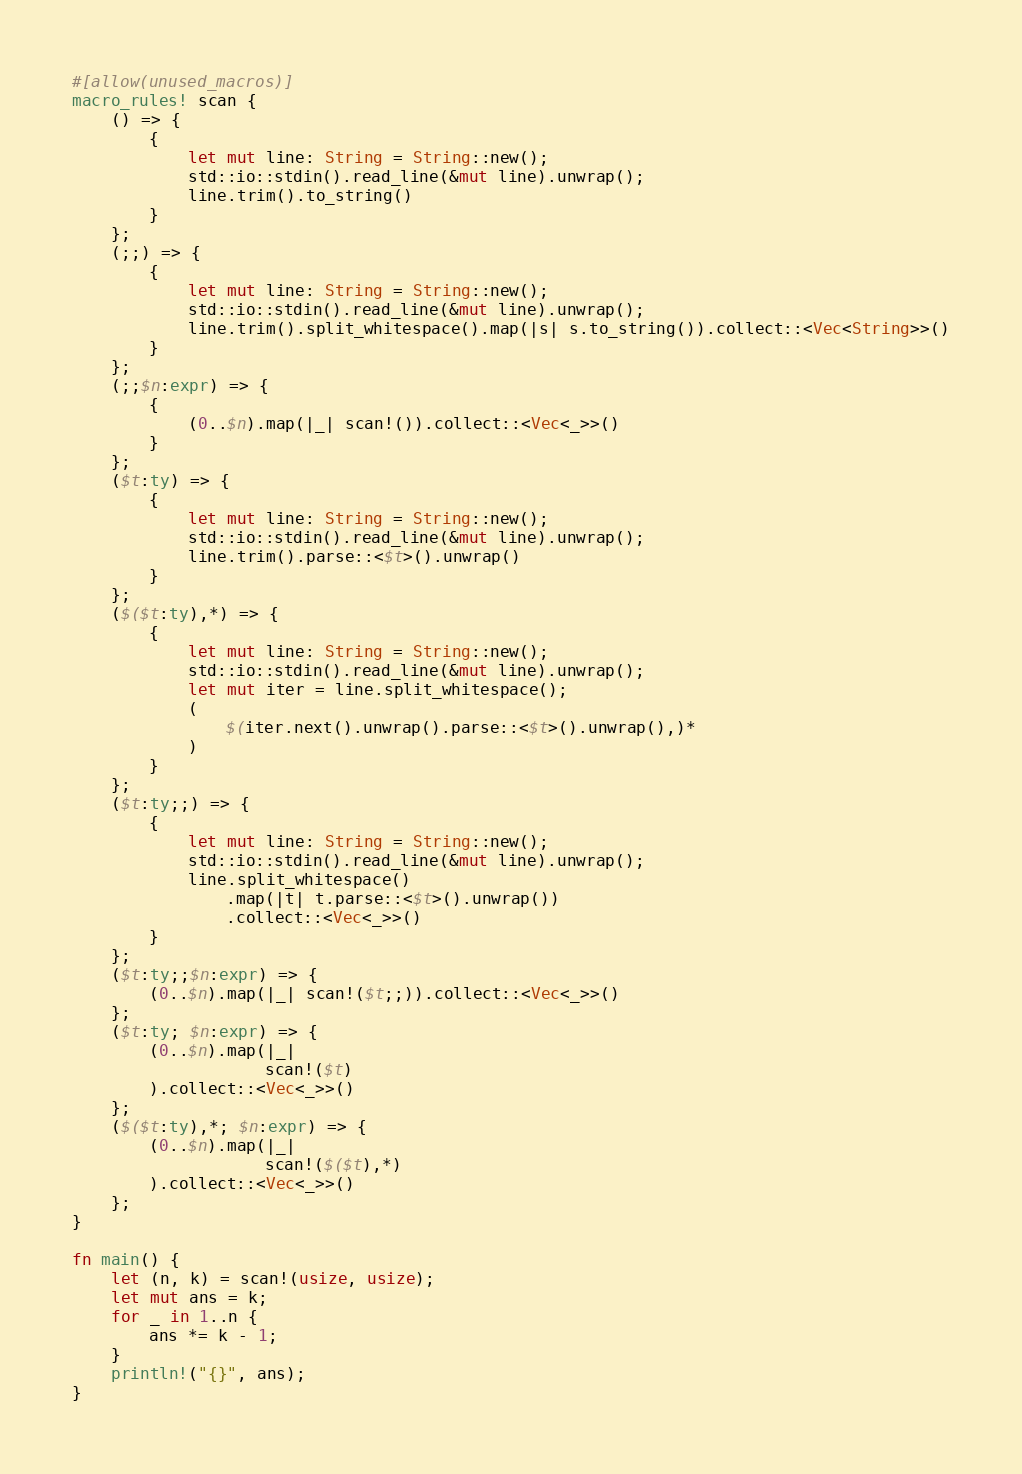<code> <loc_0><loc_0><loc_500><loc_500><_Rust_>#[allow(unused_macros)]
macro_rules! scan {
    () => {
        {
            let mut line: String = String::new();
            std::io::stdin().read_line(&mut line).unwrap();
            line.trim().to_string()
        }
    };
    (;;) => {
        {
            let mut line: String = String::new();
            std::io::stdin().read_line(&mut line).unwrap();
            line.trim().split_whitespace().map(|s| s.to_string()).collect::<Vec<String>>()
        }
    };
    (;;$n:expr) => {
        {
            (0..$n).map(|_| scan!()).collect::<Vec<_>>()
        }
    };
    ($t:ty) => {
        {
            let mut line: String = String::new();
            std::io::stdin().read_line(&mut line).unwrap();
            line.trim().parse::<$t>().unwrap()
        }
    };
    ($($t:ty),*) => {
        {
            let mut line: String = String::new();
            std::io::stdin().read_line(&mut line).unwrap();
            let mut iter = line.split_whitespace();
            (
                $(iter.next().unwrap().parse::<$t>().unwrap(),)*
            )
        }
    };
    ($t:ty;;) => {
        {
            let mut line: String = String::new();
            std::io::stdin().read_line(&mut line).unwrap();
            line.split_whitespace()
                .map(|t| t.parse::<$t>().unwrap())
                .collect::<Vec<_>>()
        }
    };
    ($t:ty;;$n:expr) => {
        (0..$n).map(|_| scan!($t;;)).collect::<Vec<_>>()
    };
    ($t:ty; $n:expr) => {
        (0..$n).map(|_|
                    scan!($t)
        ).collect::<Vec<_>>()
    };
    ($($t:ty),*; $n:expr) => {
        (0..$n).map(|_|
                    scan!($($t),*)
        ).collect::<Vec<_>>()
    };
}

fn main() {
    let (n, k) = scan!(usize, usize);
    let mut ans = k;
    for _ in 1..n {
        ans *= k - 1;
    }
    println!("{}", ans);
}
</code> 